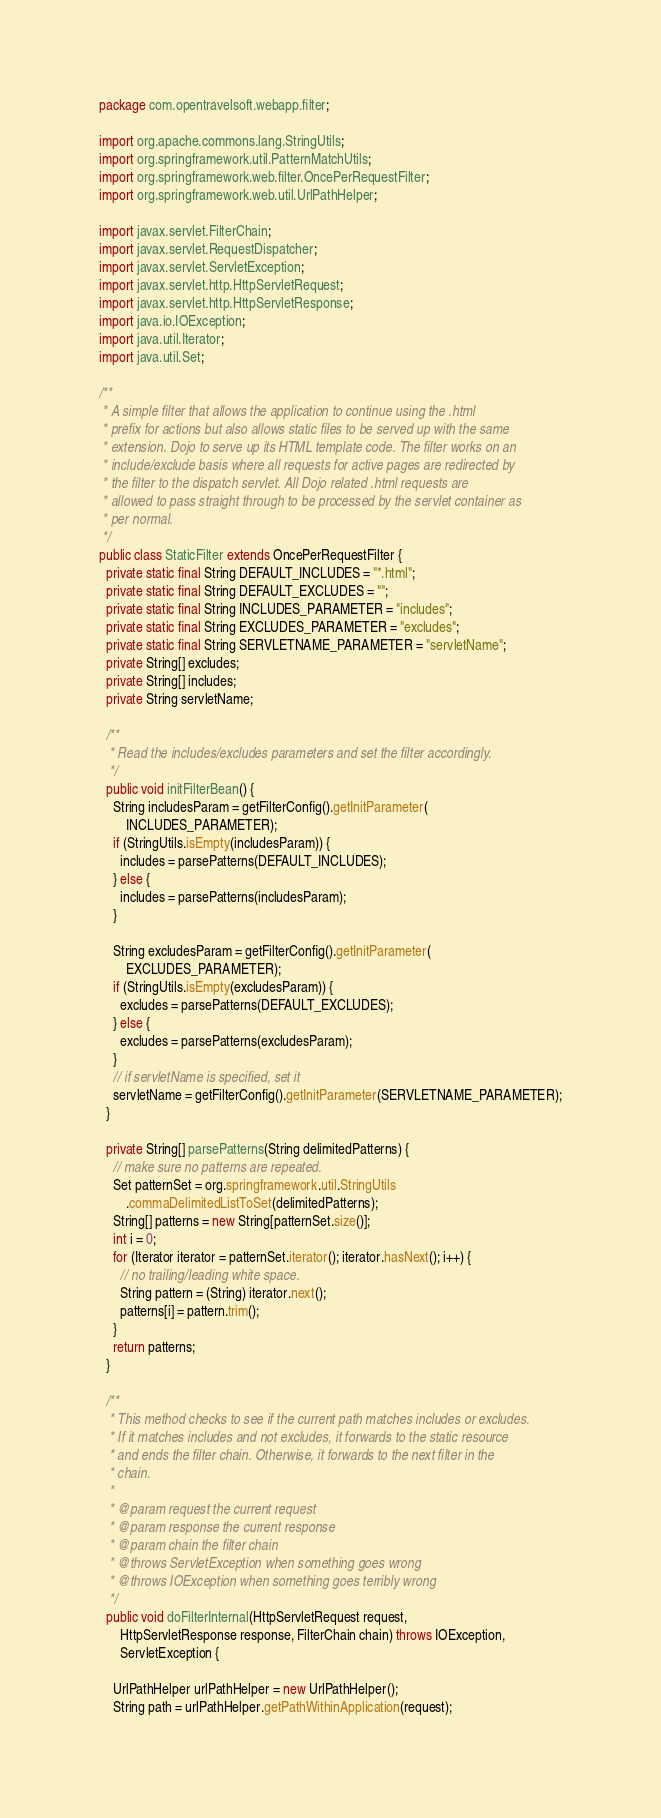Convert code to text. <code><loc_0><loc_0><loc_500><loc_500><_Java_>package com.opentravelsoft.webapp.filter;

import org.apache.commons.lang.StringUtils;
import org.springframework.util.PatternMatchUtils;
import org.springframework.web.filter.OncePerRequestFilter;
import org.springframework.web.util.UrlPathHelper;

import javax.servlet.FilterChain;
import javax.servlet.RequestDispatcher;
import javax.servlet.ServletException;
import javax.servlet.http.HttpServletRequest;
import javax.servlet.http.HttpServletResponse;
import java.io.IOException;
import java.util.Iterator;
import java.util.Set;

/**
 * A simple filter that allows the application to continue using the .html
 * prefix for actions but also allows static files to be served up with the same
 * extension. Dojo to serve up its HTML template code. The filter works on an
 * include/exclude basis where all requests for active pages are redirected by
 * the filter to the dispatch servlet. All Dojo related .html requests are
 * allowed to pass straight through to be processed by the servlet container as
 * per normal.
 */
public class StaticFilter extends OncePerRequestFilter {
  private static final String DEFAULT_INCLUDES = "*.html";
  private static final String DEFAULT_EXCLUDES = "";
  private static final String INCLUDES_PARAMETER = "includes";
  private static final String EXCLUDES_PARAMETER = "excludes";
  private static final String SERVLETNAME_PARAMETER = "servletName";
  private String[] excludes;
  private String[] includes;
  private String servletName;

  /**
   * Read the includes/excludes parameters and set the filter accordingly.
   */
  public void initFilterBean() {
    String includesParam = getFilterConfig().getInitParameter(
        INCLUDES_PARAMETER);
    if (StringUtils.isEmpty(includesParam)) {
      includes = parsePatterns(DEFAULT_INCLUDES);
    } else {
      includes = parsePatterns(includesParam);
    }

    String excludesParam = getFilterConfig().getInitParameter(
        EXCLUDES_PARAMETER);
    if (StringUtils.isEmpty(excludesParam)) {
      excludes = parsePatterns(DEFAULT_EXCLUDES);
    } else {
      excludes = parsePatterns(excludesParam);
    }
    // if servletName is specified, set it
    servletName = getFilterConfig().getInitParameter(SERVLETNAME_PARAMETER);
  }

  private String[] parsePatterns(String delimitedPatterns) {
    // make sure no patterns are repeated.
    Set patternSet = org.springframework.util.StringUtils
        .commaDelimitedListToSet(delimitedPatterns);
    String[] patterns = new String[patternSet.size()];
    int i = 0;
    for (Iterator iterator = patternSet.iterator(); iterator.hasNext(); i++) {
      // no trailing/leading white space.
      String pattern = (String) iterator.next();
      patterns[i] = pattern.trim();
    }
    return patterns;
  }

  /**
   * This method checks to see if the current path matches includes or excludes.
   * If it matches includes and not excludes, it forwards to the static resource
   * and ends the filter chain. Otherwise, it forwards to the next filter in the
   * chain.
   * 
   * @param request the current request
   * @param response the current response
   * @param chain the filter chain
   * @throws ServletException when something goes wrong
   * @throws IOException when something goes terribly wrong
   */
  public void doFilterInternal(HttpServletRequest request,
      HttpServletResponse response, FilterChain chain) throws IOException,
      ServletException {

    UrlPathHelper urlPathHelper = new UrlPathHelper();
    String path = urlPathHelper.getPathWithinApplication(request);</code> 